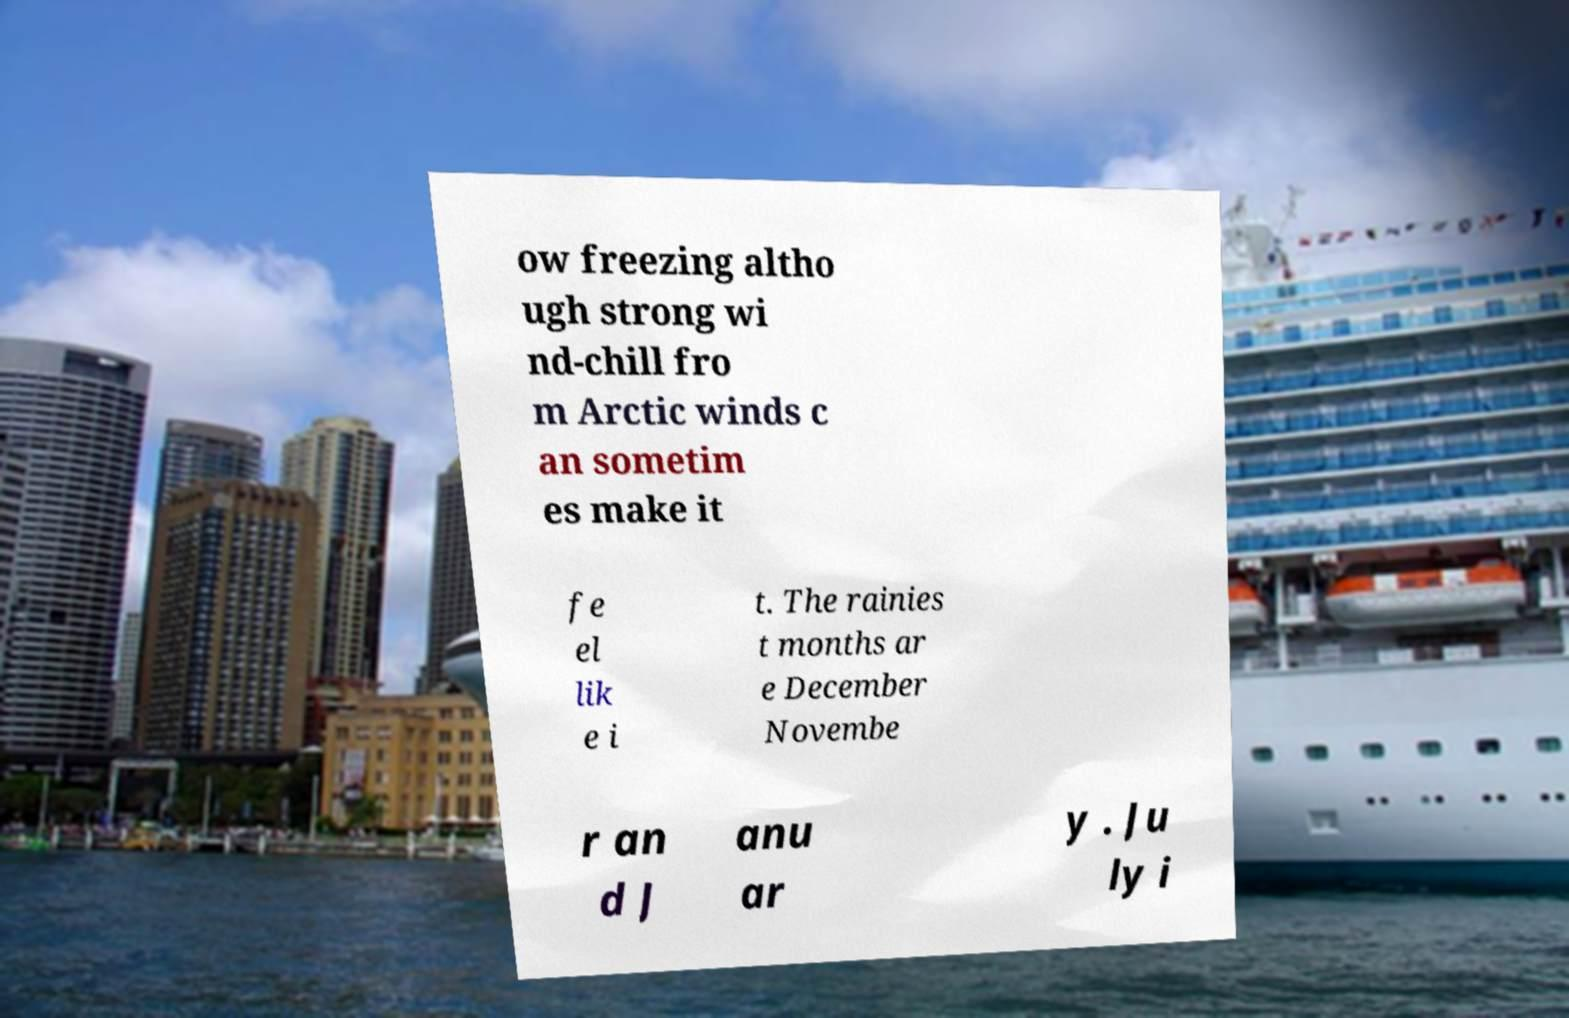Can you accurately transcribe the text from the provided image for me? ow freezing altho ugh strong wi nd-chill fro m Arctic winds c an sometim es make it fe el lik e i t. The rainies t months ar e December Novembe r an d J anu ar y . Ju ly i 